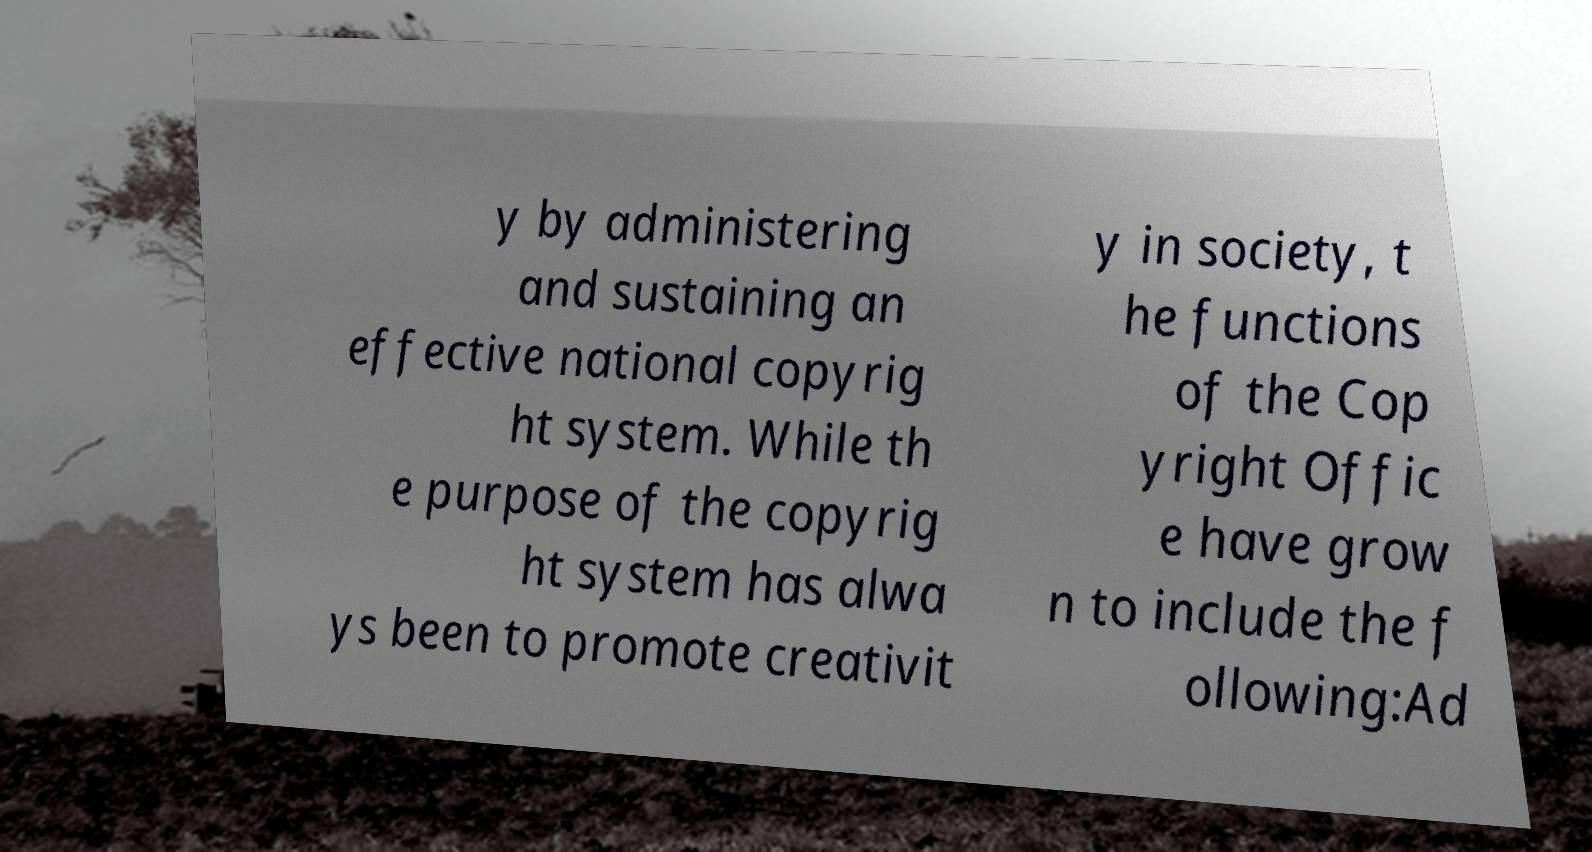For documentation purposes, I need the text within this image transcribed. Could you provide that? y by administering and sustaining an effective national copyrig ht system. While th e purpose of the copyrig ht system has alwa ys been to promote creativit y in society, t he functions of the Cop yright Offic e have grow n to include the f ollowing:Ad 